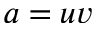Convert formula to latex. <formula><loc_0><loc_0><loc_500><loc_500>a = u v</formula> 